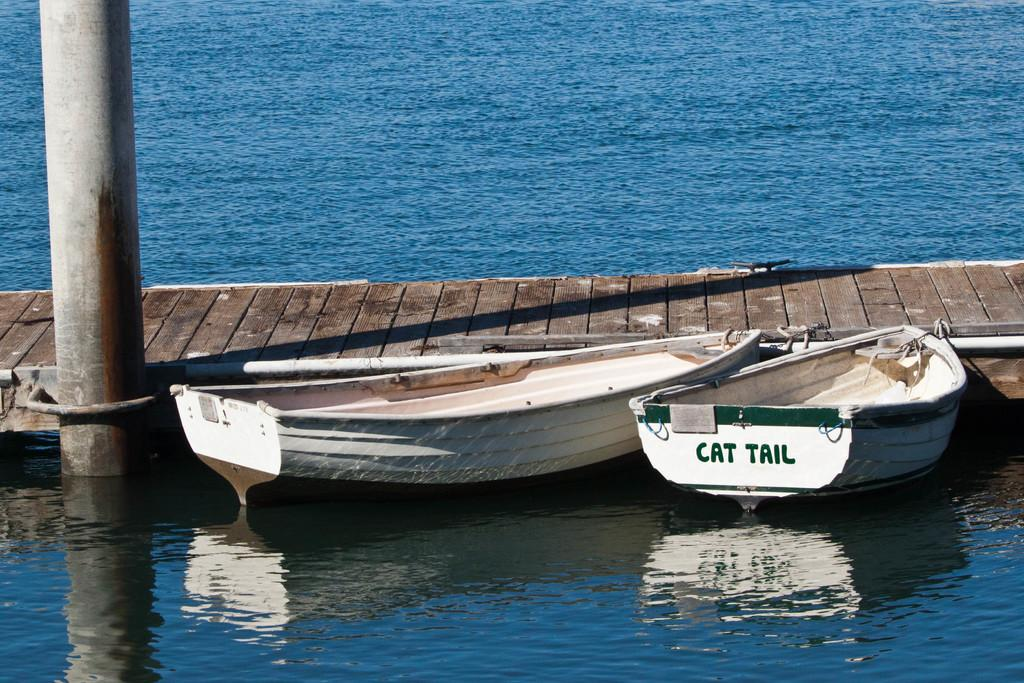How many boats can be seen in the image? There are two boats in the image. Where are the boats located? The boats are on the surface of a river. What else is present in the image besides the boats? There is a pole and a path visible in the image. What color is the shirt worn by the person in the image? There is no person or shirt present in the image; it only features two boats, a pole, and a path. 